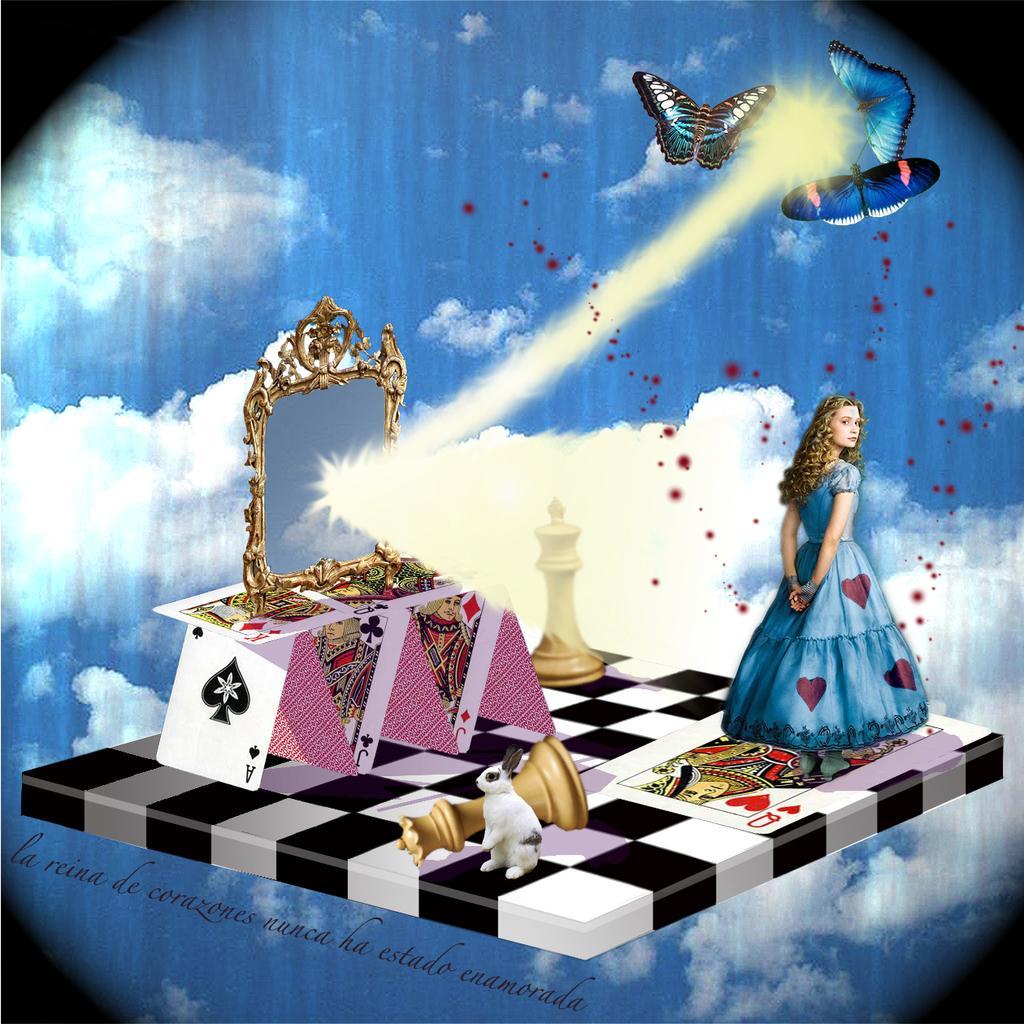Could you give a brief overview of what you see in this image? This is a cartoon image. On the right side of the image we can see butterflies and a girl. On the left side of the image we can see chess coins, cards and a mirror. In the background there are sky and clouds. 